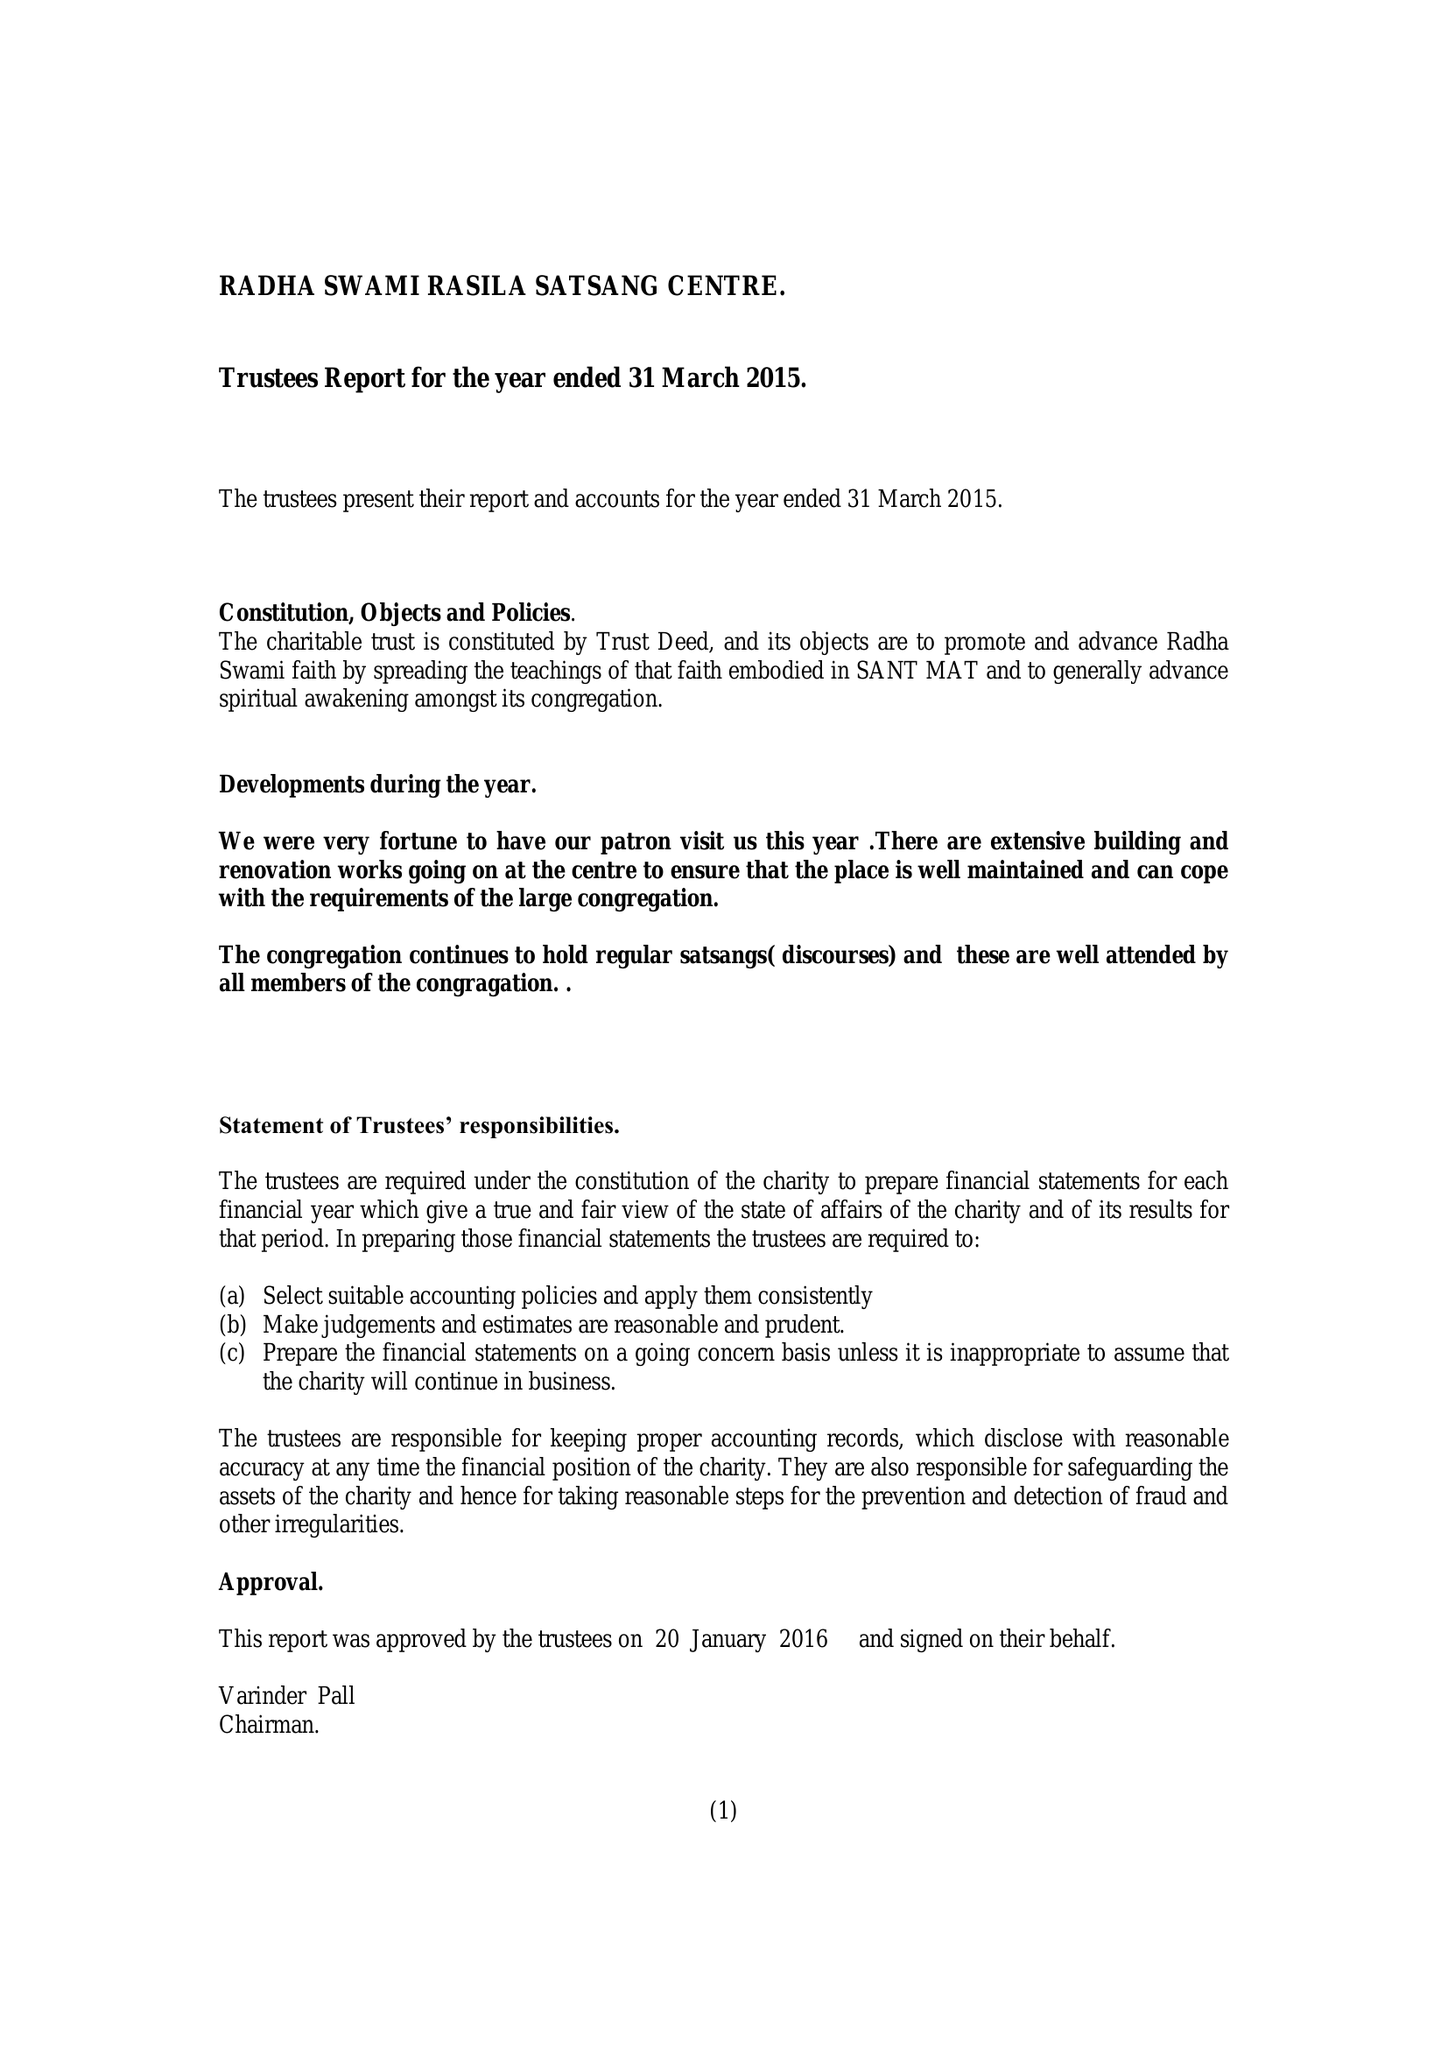What is the value for the charity_name?
Answer the question using a single word or phrase. Radha Swami Rasila Satsang Centre 